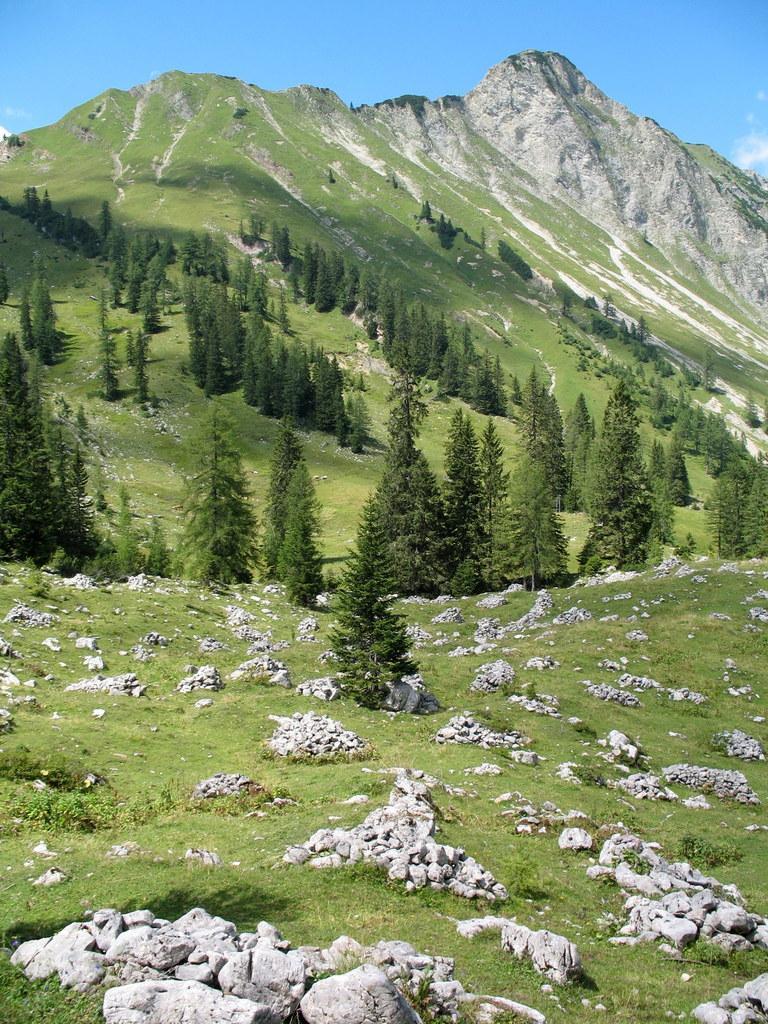In one or two sentences, can you explain what this image depicts? In the image we can see trees, stones, grass, the mountain and the sky. 